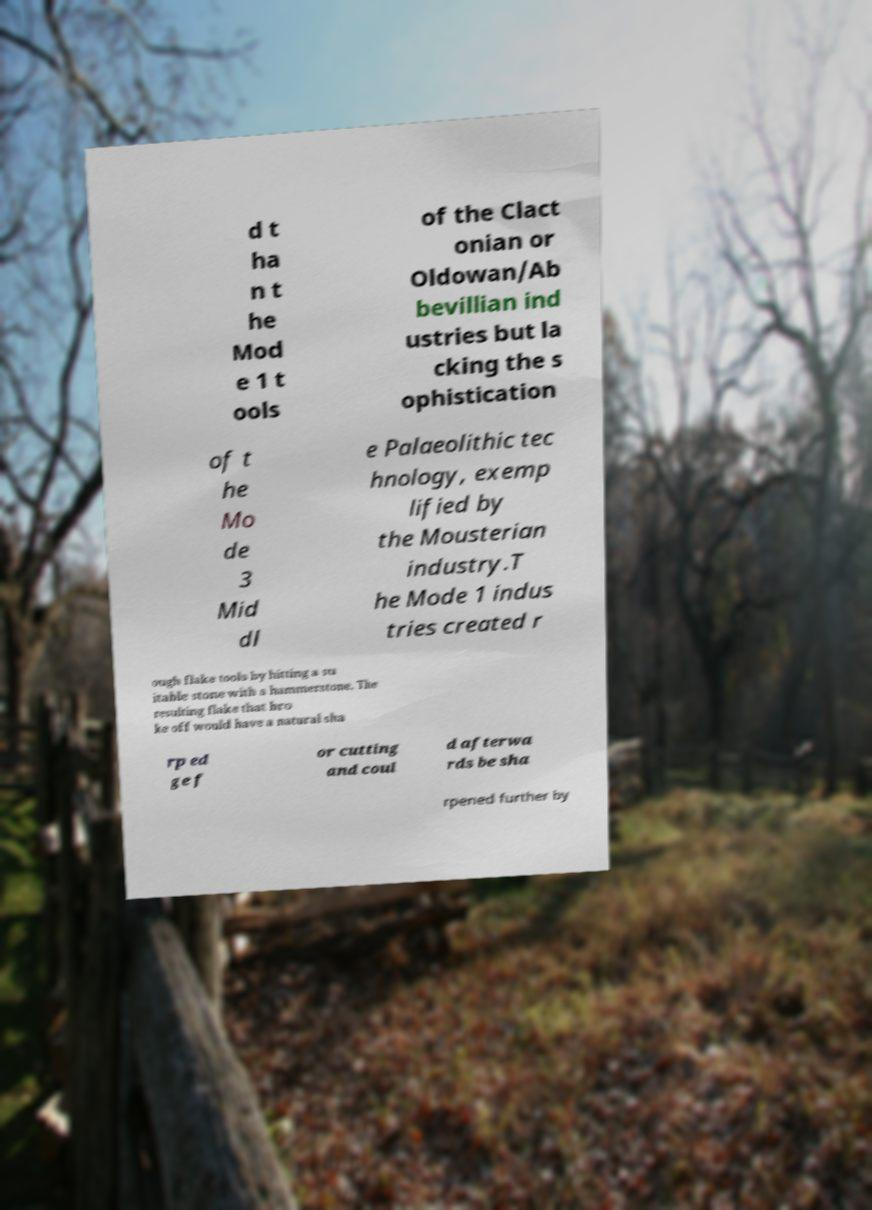Please identify and transcribe the text found in this image. d t ha n t he Mod e 1 t ools of the Clact onian or Oldowan/Ab bevillian ind ustries but la cking the s ophistication of t he Mo de 3 Mid dl e Palaeolithic tec hnology, exemp lified by the Mousterian industry.T he Mode 1 indus tries created r ough flake tools by hitting a su itable stone with a hammerstone. The resulting flake that bro ke off would have a natural sha rp ed ge f or cutting and coul d afterwa rds be sha rpened further by 